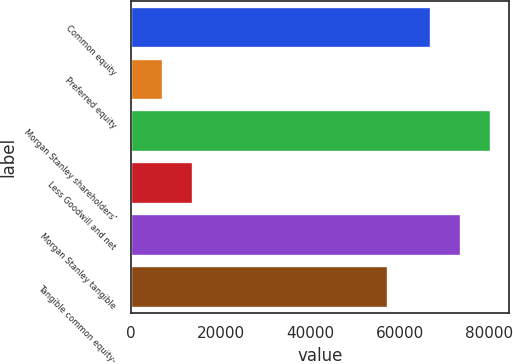<chart> <loc_0><loc_0><loc_500><loc_500><bar_chart><fcel>Common equity<fcel>Preferred equity<fcel>Morgan Stanley shareholders'<fcel>Less Goodwill and net<fcel>Morgan Stanley tangible<fcel>Tangible common equity-<nl><fcel>66936<fcel>7174<fcel>80323.2<fcel>13867.6<fcel>73629.6<fcel>57275<nl></chart> 